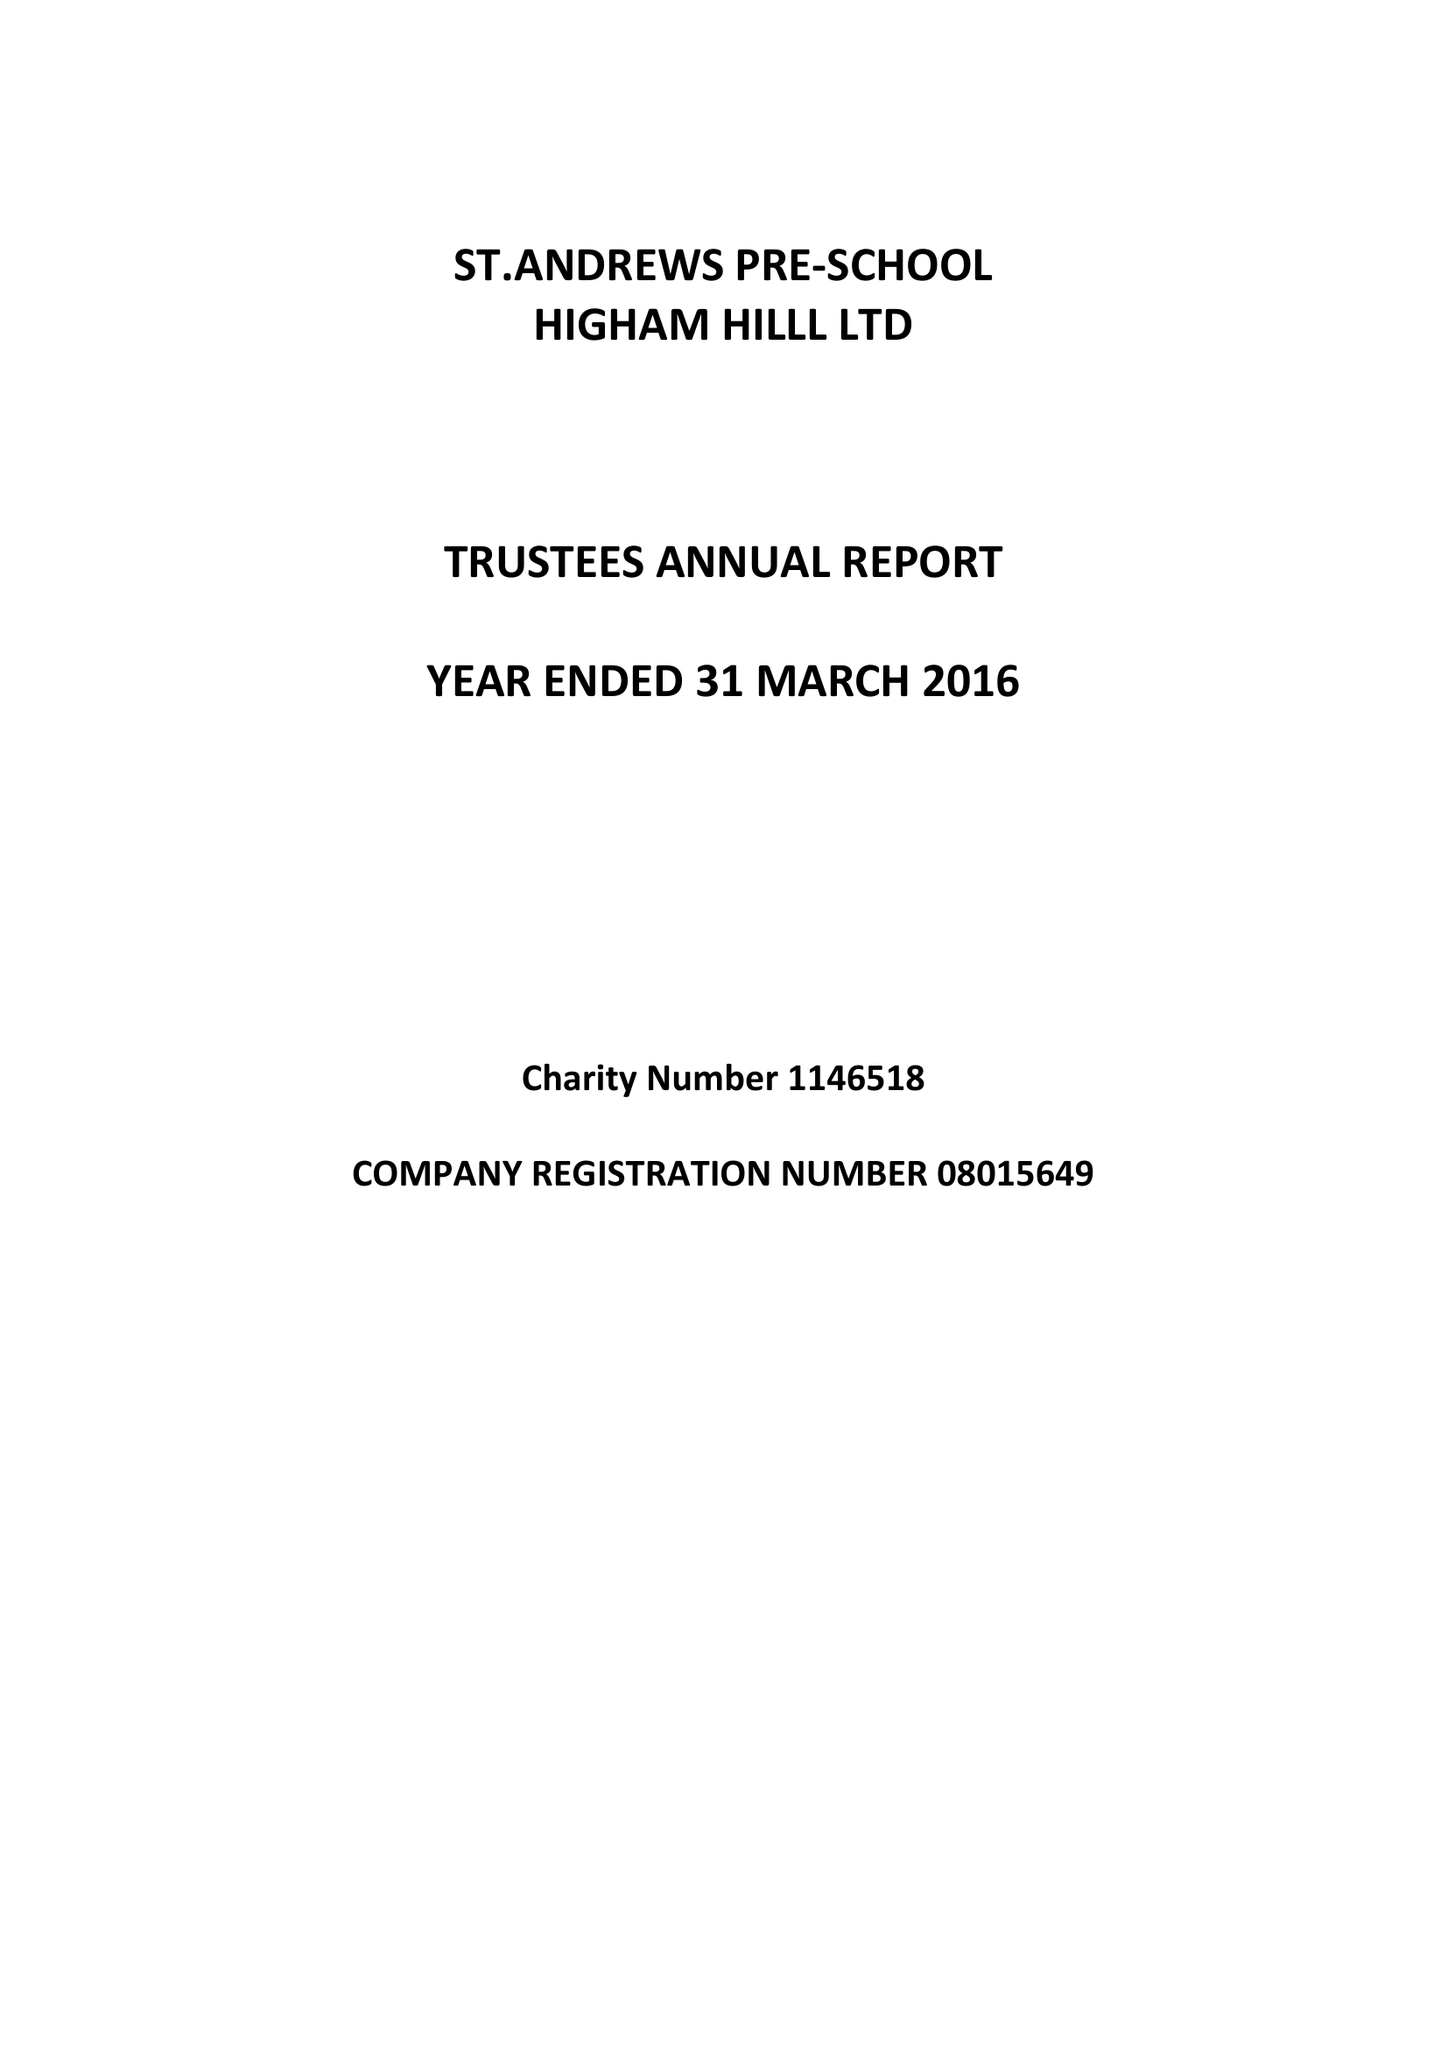What is the value for the charity_number?
Answer the question using a single word or phrase. 1146518 